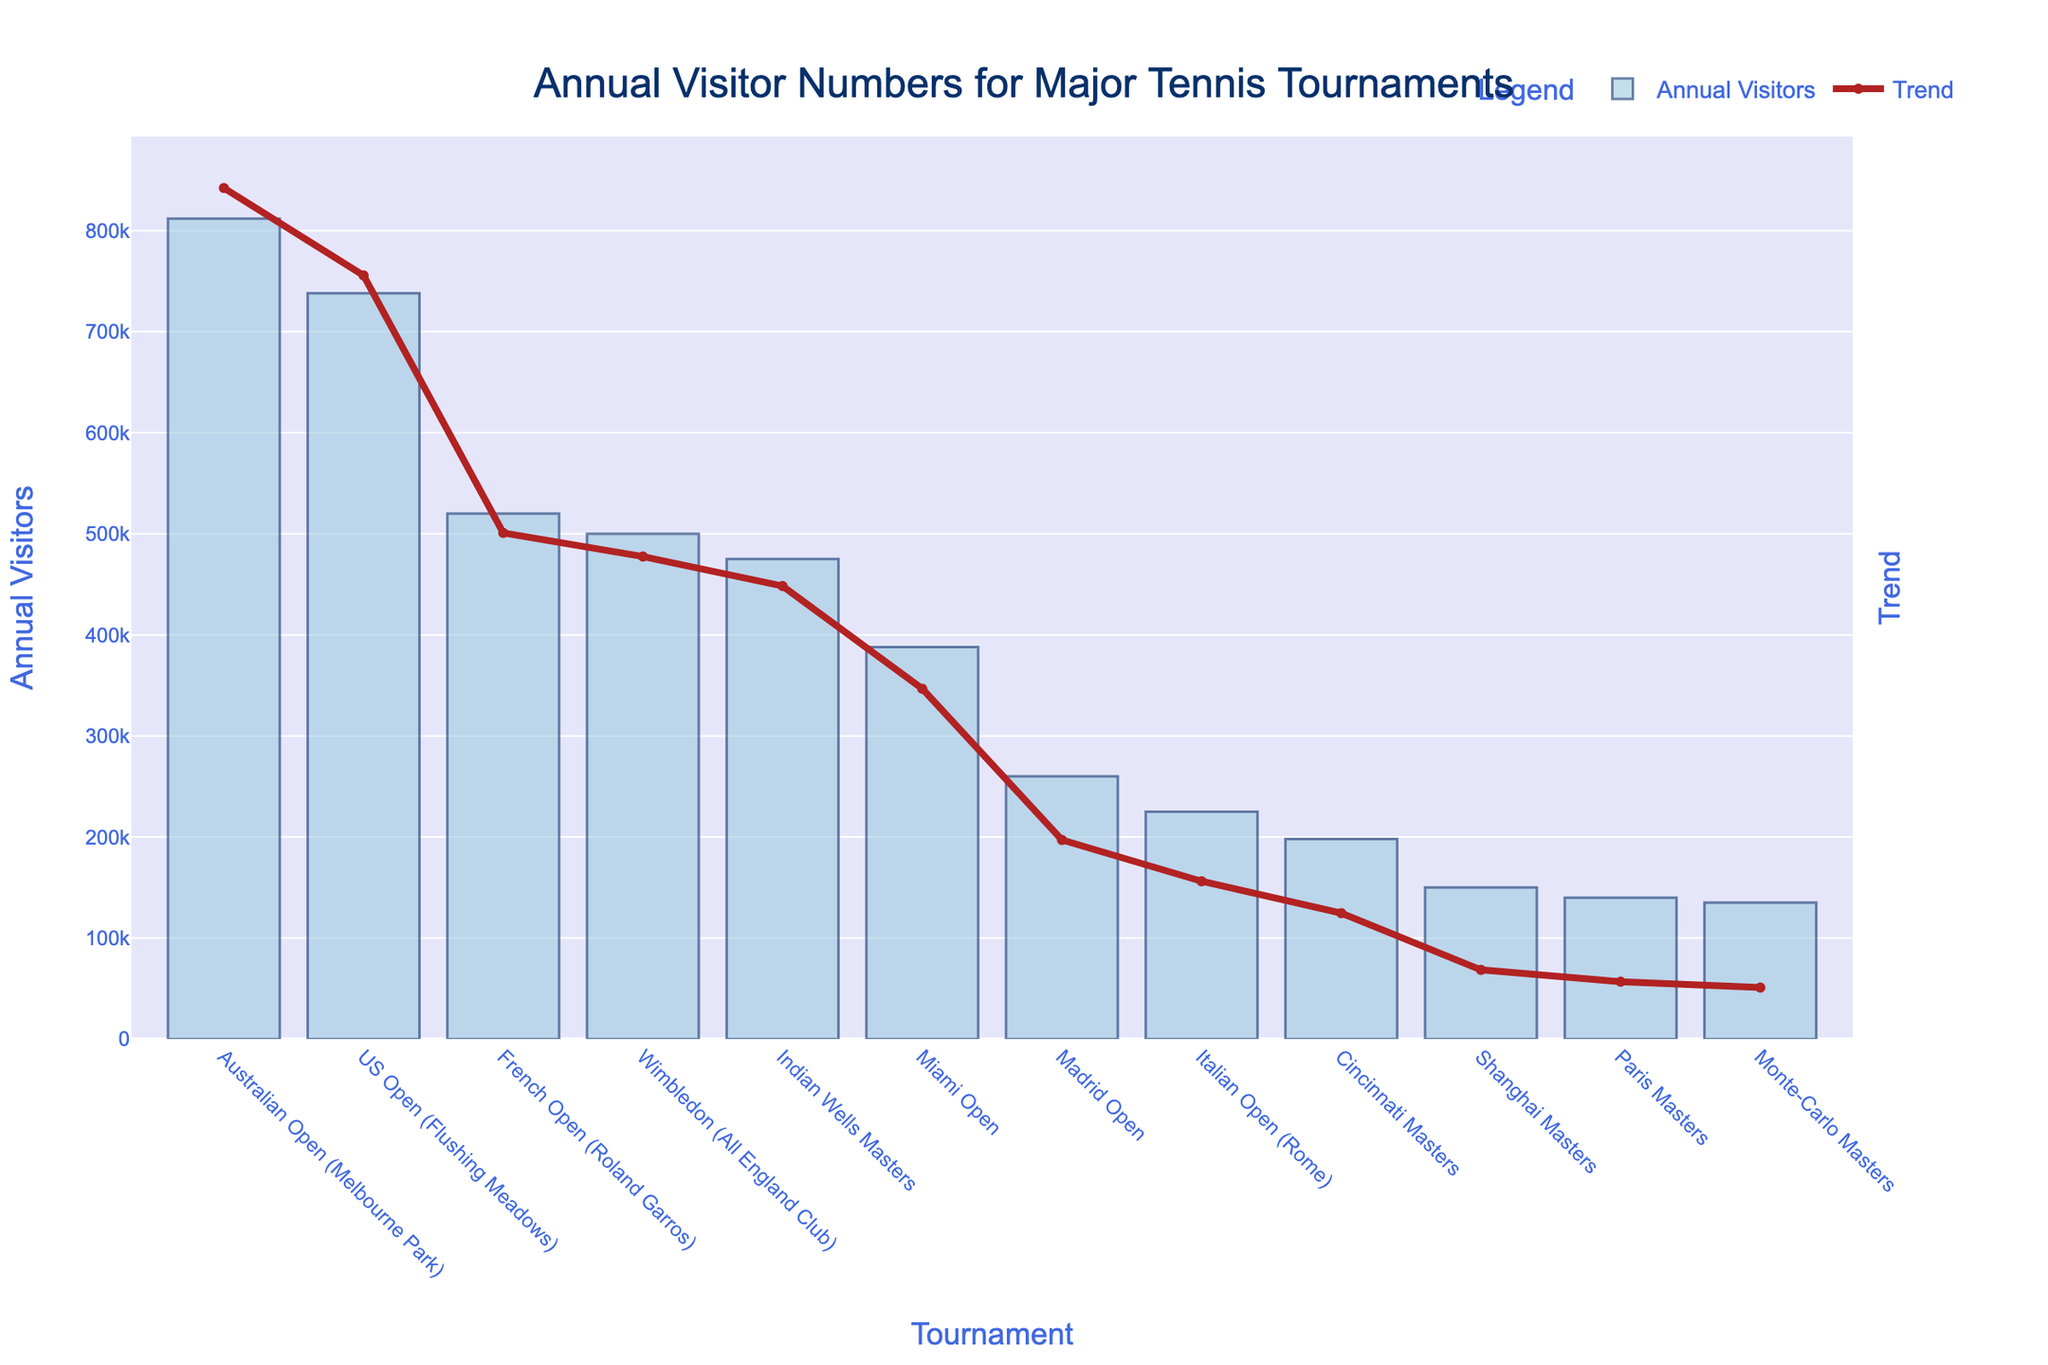What tournament has the highest annual visitors? The highest bar on the chart represents the tournament with the most visitors. The Australian Open (Melbourne Park) has the highest annual visitors.
Answer: Australian Open (Melbourne Park) Which Grand Slam tournament has fewer annual visitors than the US Open but more than the French Open? The US Open has a bar slightly lower than the Australian Open, and the French Open has a bar even lower. Wimbledon falls between these two tournaments.
Answer: Wimbledon (All England Club) What is the difference between the annual visitors of the Australian Open and the French Open? The bar for the Australian Open reaches 812,000, while the bar for the French Open reaches 520,000. Subtracting these values gives the difference.
Answer: 292,000 Which tournament has the lowest annual visitors? The shortest bar on the chart signifies the tournament with the fewest visitors. The Monte-Carlo Masters has the lowest annual visitors.
Answer: Monte-Carlo Masters What's the combined annual visitor count for the four Grand Slam tournaments? Adding the annual visitors for the Australian Open (812,000), the French Open (520,000), Wimbledon (500,000), and the US Open (738,000) gives the total.
Answer: 2,570,000 How many more visitors does Indian Wells Masters have compared to the Cincinnati Masters? The bar for Indian Wells Masters shows 475,000 visitors, and the bar for the Cincinnati Masters shows 198,000 visitors. The difference between these two values is 277,000.
Answer: 277,000 What is the average number of annual visitors for the non-Grand Slam tournaments listed? Summing the annual visitors for Indian Wells Masters (475,000), Miami Open (388,000), Monte-Carlo Masters (135,000), Madrid Open (260,000), Italian Open (225,000), Cincinnati Masters (198,000), Shanghai Masters (150,000), and Paris Masters (140,000), getting 1,971,000, and dividing by the number of tournaments (8) gives the average.
Answer: 246,375 How many more visitors does the US Open have compared to Wimbledon? The bar for the US Open indicates 738,000 visitors, and the bar for Wimbledon indicates 500,000 visitors. The difference is 238,000.
Answer: 238,000 What tournament is represented by the third-tallest bar on the chart? Observing the chart, the third-tallest bar belongs to the US Open, which is slightly shorter than the Australian Open and taller than the French Open.
Answer: US Open (Flushing Meadows) What is the median value of annual visitors for all the tournaments listed? To find the median, first list the annual visitors in ascending order: 135,000, 140,000, 150,000, 198,000, 225,000, 260,000, 388,000, 475,000, 500,000, 520,000, 738,000, 812,000. With 12 values, the median is the average of the 6th and 7th values: (260,000 + 388,000) / 2 = 324,000.
Answer: 324,000 